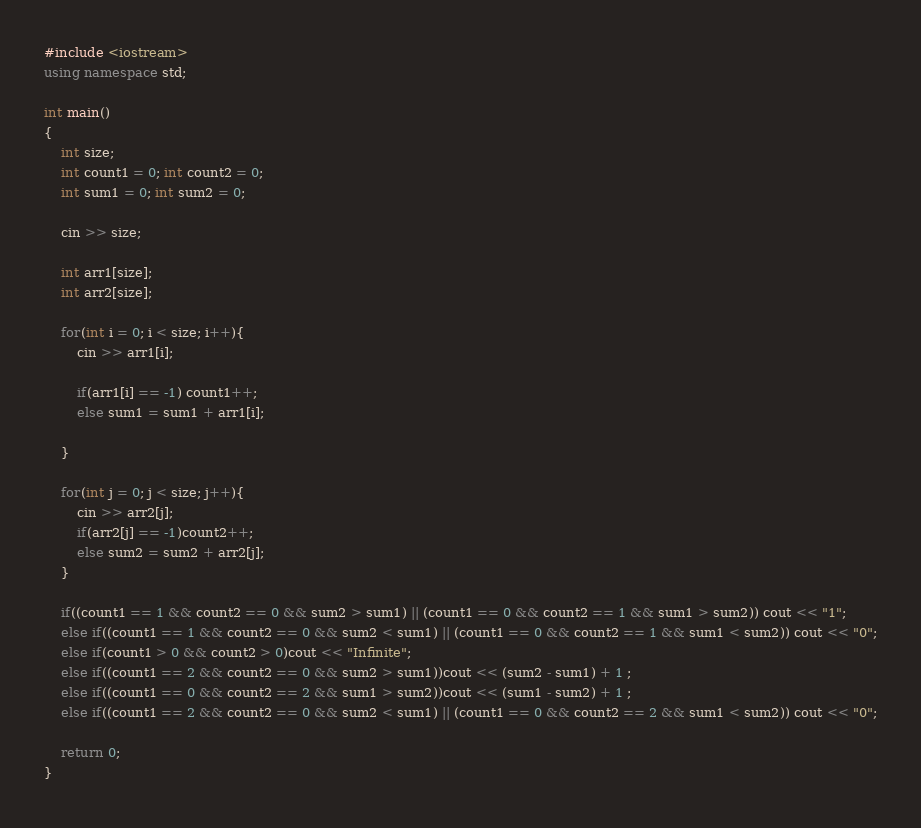<code> <loc_0><loc_0><loc_500><loc_500><_C++_>#include <iostream>
using namespace std;
 
int main()
{
    int size;
    int count1 = 0; int count2 = 0;
    int sum1 = 0; int sum2 = 0;
 
    cin >> size;
 
    int arr1[size];
    int arr2[size];
 
    for(int i = 0; i < size; i++){
        cin >> arr1[i];
 
        if(arr1[i] == -1) count1++;
        else sum1 = sum1 + arr1[i];
 
    }
 
    for(int j = 0; j < size; j++){
        cin >> arr2[j];
        if(arr2[j] == -1)count2++;
        else sum2 = sum2 + arr2[j];
    }
 
    if((count1 == 1 && count2 == 0 && sum2 > sum1) || (count1 == 0 && count2 == 1 && sum1 > sum2)) cout << "1";
    else if((count1 == 1 && count2 == 0 && sum2 < sum1) || (count1 == 0 && count2 == 1 && sum1 < sum2)) cout << "0";
    else if(count1 > 0 && count2 > 0)cout << "Infinite";
    else if((count1 == 2 && count2 == 0 && sum2 > sum1))cout << (sum2 - sum1) + 1 ;
    else if((count1 == 0 && count2 == 2 && sum1 > sum2))cout << (sum1 - sum2) + 1 ;
    else if((count1 == 2 && count2 == 0 && sum2 < sum1) || (count1 == 0 && count2 == 2 && sum1 < sum2)) cout << "0";
 
    return 0;
}
</code> 